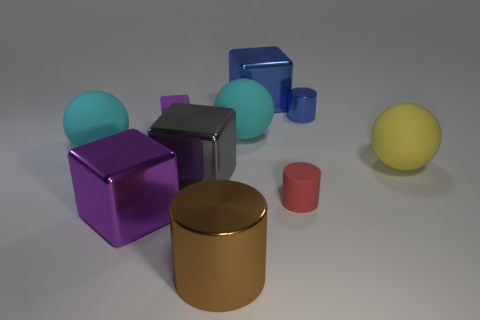Subtract all large gray metallic blocks. How many blocks are left? 3 Subtract all blue cylinders. How many cylinders are left? 2 Subtract 1 blue cylinders. How many objects are left? 9 Subtract all cubes. How many objects are left? 6 Subtract 3 balls. How many balls are left? 0 Subtract all red cubes. Subtract all blue balls. How many cubes are left? 4 Subtract all red cylinders. How many green balls are left? 0 Subtract all rubber cylinders. Subtract all small things. How many objects are left? 6 Add 3 metal blocks. How many metal blocks are left? 6 Add 6 tiny purple rubber things. How many tiny purple rubber things exist? 7 